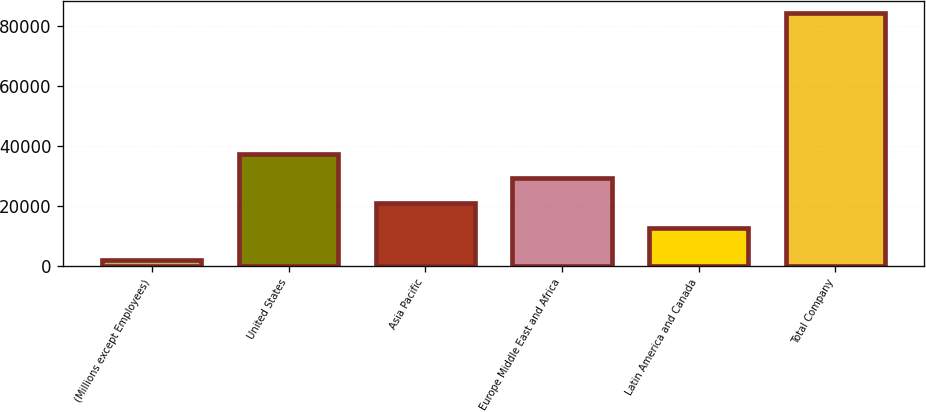Convert chart. <chart><loc_0><loc_0><loc_500><loc_500><bar_chart><fcel>(Millions except Employees)<fcel>United States<fcel>Asia Pacific<fcel>Europe Middle East and Africa<fcel>Latin America and Canada<fcel>Total Company<nl><fcel>2011<fcel>37480.1<fcel>21042.7<fcel>29261.4<fcel>12824<fcel>84198<nl></chart> 